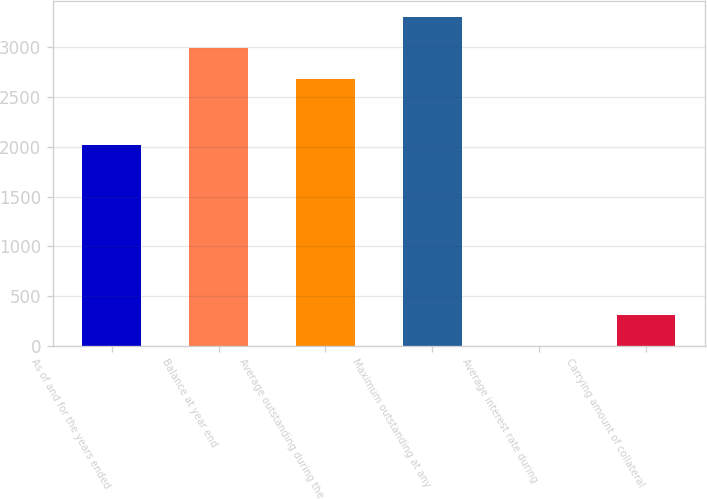<chart> <loc_0><loc_0><loc_500><loc_500><bar_chart><fcel>As of and for the years ended<fcel>Balance at year end<fcel>Average outstanding during the<fcel>Maximum outstanding at any<fcel>Average interest rate during<fcel>Carrying amount of collateral<nl><fcel>2017<fcel>2990.46<fcel>2677.5<fcel>3303.42<fcel>1.17<fcel>314.13<nl></chart> 